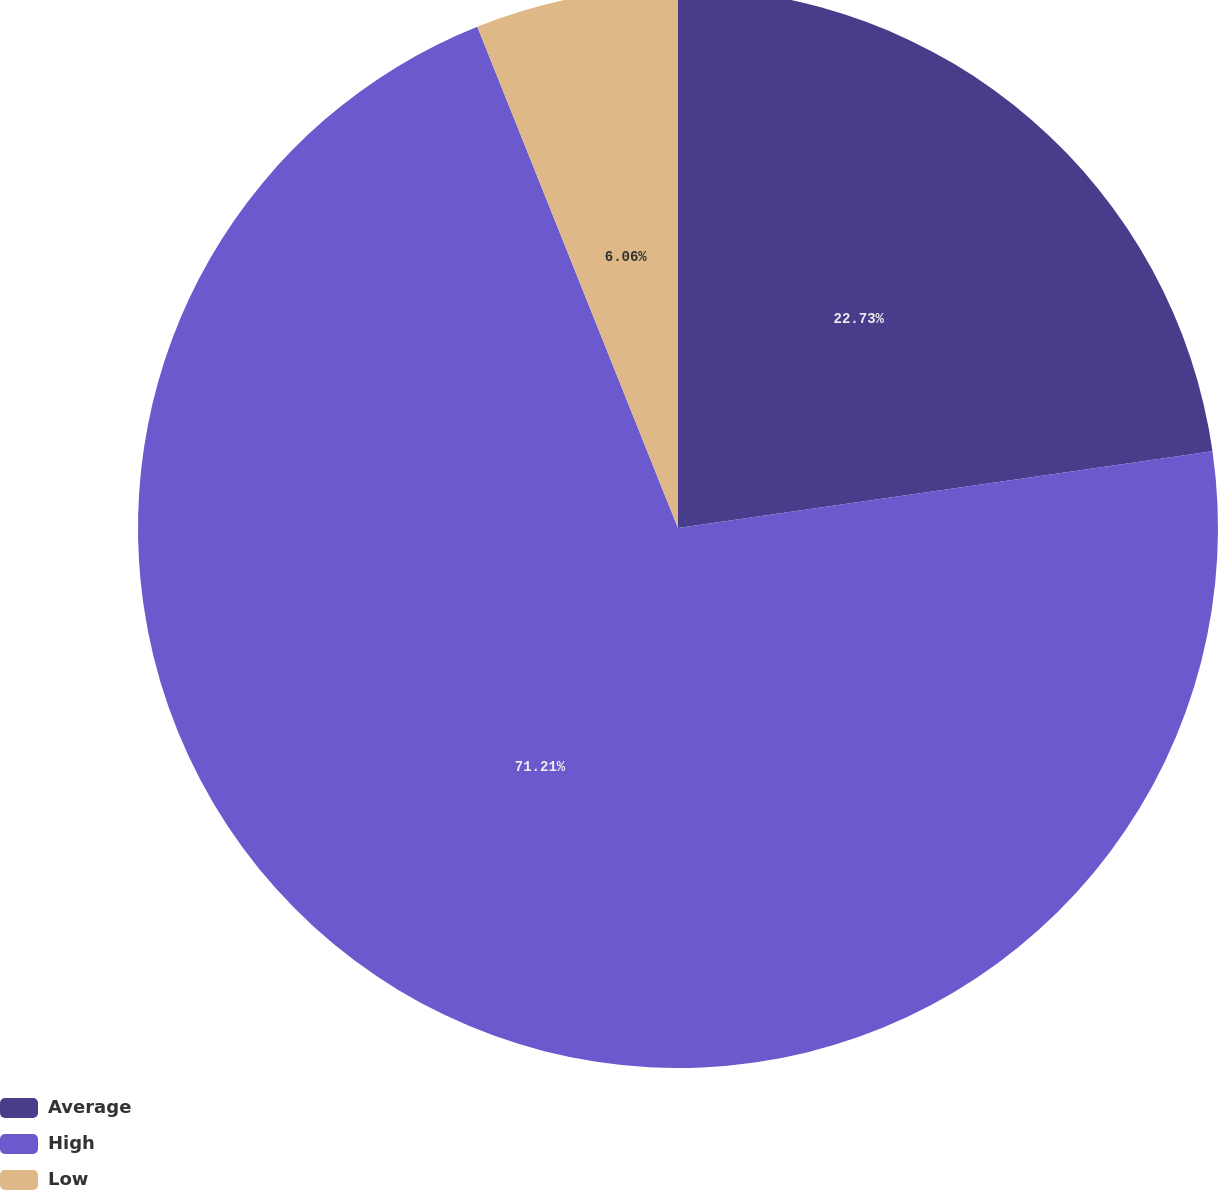<chart> <loc_0><loc_0><loc_500><loc_500><pie_chart><fcel>Average<fcel>High<fcel>Low<nl><fcel>22.73%<fcel>71.21%<fcel>6.06%<nl></chart> 